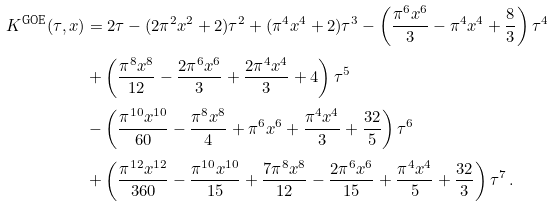<formula> <loc_0><loc_0><loc_500><loc_500>K ^ { \text {GOE} } ( \tau , x ) & = 2 \tau - ( 2 \pi ^ { 2 } x ^ { 2 } + 2 ) \tau ^ { 2 } + ( \pi ^ { 4 } x ^ { 4 } + 2 ) \tau ^ { 3 } - \left ( \frac { \pi ^ { 6 } x ^ { 6 } } { 3 } - \pi ^ { 4 } x ^ { 4 } + \frac { 8 } { 3 } \right ) \tau ^ { 4 } \\ & + \left ( \frac { \pi ^ { 8 } x ^ { 8 } } { 1 2 } - \frac { 2 \pi ^ { 6 } x ^ { 6 } } { 3 } + \frac { 2 \pi ^ { 4 } x ^ { 4 } } { 3 } + 4 \right ) \tau ^ { 5 } \\ & - \left ( \frac { \pi ^ { 1 0 } x ^ { 1 0 } } { 6 0 } - \frac { \pi ^ { 8 } x ^ { 8 } } { 4 } + \pi ^ { 6 } x ^ { 6 } + \frac { \pi ^ { 4 } x ^ { 4 } } { 3 } + \frac { 3 2 } { 5 } \right ) \tau ^ { 6 } \\ & + \left ( \frac { \pi ^ { 1 2 } x ^ { 1 2 } } { 3 6 0 } - \frac { \pi ^ { 1 0 } x ^ { 1 0 } } { 1 5 } + \frac { 7 \pi ^ { 8 } x ^ { 8 } } { 1 2 } - \frac { 2 \pi ^ { 6 } x ^ { 6 } } { 1 5 } + \frac { \pi ^ { 4 } x ^ { 4 } } { 5 } + \frac { 3 2 } { 3 } \right ) \tau ^ { 7 } \, .</formula> 